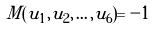<formula> <loc_0><loc_0><loc_500><loc_500>M ( u _ { 1 } , u _ { 2 } , \dots , u _ { 6 } ) = - 1</formula> 